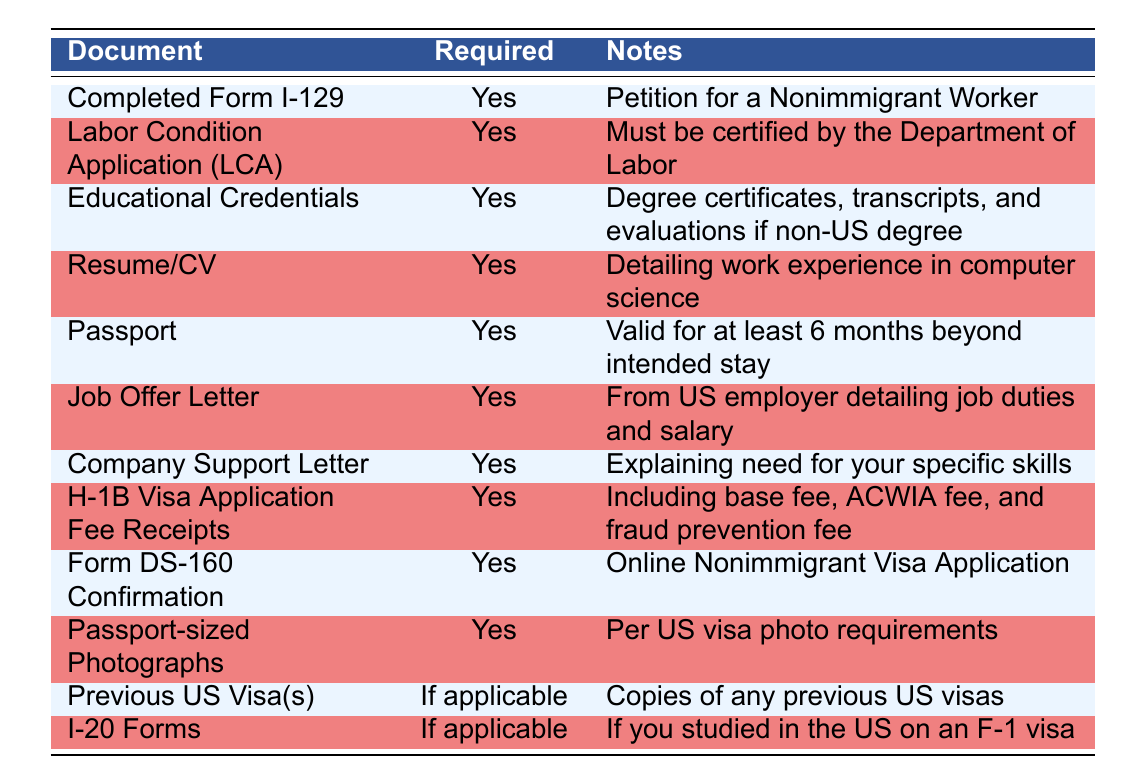What document is required for the petition for a nonimmigrant worker? The table shows that the "Completed Form I-129" is required for the petition for a nonimmigrant worker.
Answer: Completed Form I-129 Is the Labor Condition Application (LCA) required? Yes, the table clearly indicates that the LCA is required as indicated by the "Yes" in the Required column.
Answer: Yes How many documents are required in total? Counting the rows in the table, there are 10 documents listed. Therefore, the total number of required documents is 10.
Answer: 10 What are the notes regarding educational credentials? The table specifies that the notes for Educational Credentials include "Degree certificates, transcripts, and evaluations if non-US degree."
Answer: Degree certificates, transcripts, and evaluations if non-US degree If a candidate studied in the US on an F-1 visa, which document is applicable? The table indicates that "I-20 Forms" are applicable for candidates who studied in the US on an F-1 visa, as noted in the Required column.
Answer: I-20 Forms How many documents have "If applicable" in the Required column? By examining the Required column, "Previous US Visa(s)" and "I-20 Forms" are the two documents with "If applicable." Therefore, the count of such documents is 2.
Answer: 2 Is the Company Support Letter necessary for the application? The table confirms that the Company Support Letter is required, marked with "Yes" in the Required column.
Answer: Yes What documents are needed related to the applicant's previous US visas? The table specifies that "Previous US Visa(s)" are needed if applicable and requires copies of any previous US visas.
Answer: Previous US Visa(s) What document provides confirmation of the online nonimmigrant visa application? The table states that the "Form DS-160 Confirmation" provides confirmation of the online nonimmigrant visa application.
Answer: Form DS-160 Confirmation Which document notes that it must be valid for at least 6 months beyond intended stay? The table mentions that the "Passport" must be valid for at least 6 months beyond the intended stay in the US.
Answer: Passport 